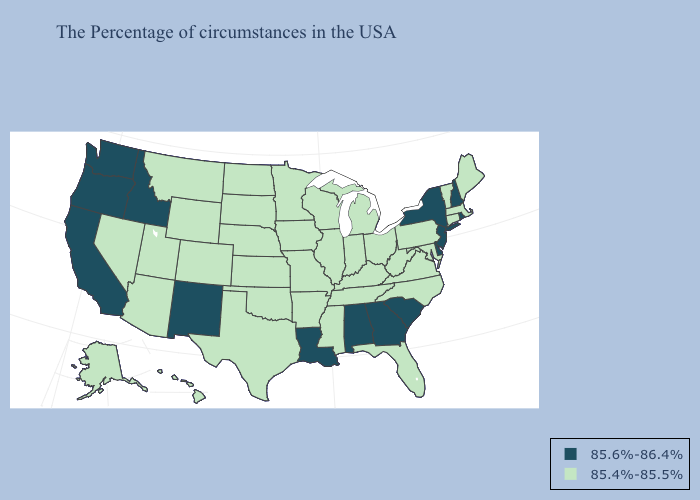Which states have the lowest value in the Northeast?
Quick response, please. Maine, Massachusetts, Vermont, Connecticut, Pennsylvania. What is the value of Montana?
Concise answer only. 85.4%-85.5%. Does Missouri have the highest value in the USA?
Be succinct. No. What is the highest value in states that border Louisiana?
Be succinct. 85.4%-85.5%. What is the value of Florida?
Give a very brief answer. 85.4%-85.5%. Name the states that have a value in the range 85.4%-85.5%?
Keep it brief. Maine, Massachusetts, Vermont, Connecticut, Maryland, Pennsylvania, Virginia, North Carolina, West Virginia, Ohio, Florida, Michigan, Kentucky, Indiana, Tennessee, Wisconsin, Illinois, Mississippi, Missouri, Arkansas, Minnesota, Iowa, Kansas, Nebraska, Oklahoma, Texas, South Dakota, North Dakota, Wyoming, Colorado, Utah, Montana, Arizona, Nevada, Alaska, Hawaii. Does Maine have the same value as Nebraska?
Keep it brief. Yes. Name the states that have a value in the range 85.6%-86.4%?
Short answer required. Rhode Island, New Hampshire, New York, New Jersey, Delaware, South Carolina, Georgia, Alabama, Louisiana, New Mexico, Idaho, California, Washington, Oregon. Name the states that have a value in the range 85.6%-86.4%?
Quick response, please. Rhode Island, New Hampshire, New York, New Jersey, Delaware, South Carolina, Georgia, Alabama, Louisiana, New Mexico, Idaho, California, Washington, Oregon. How many symbols are there in the legend?
Quick response, please. 2. Name the states that have a value in the range 85.6%-86.4%?
Keep it brief. Rhode Island, New Hampshire, New York, New Jersey, Delaware, South Carolina, Georgia, Alabama, Louisiana, New Mexico, Idaho, California, Washington, Oregon. Which states have the lowest value in the South?
Keep it brief. Maryland, Virginia, North Carolina, West Virginia, Florida, Kentucky, Tennessee, Mississippi, Arkansas, Oklahoma, Texas. Is the legend a continuous bar?
Answer briefly. No. Does the map have missing data?
Short answer required. No. 